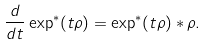Convert formula to latex. <formula><loc_0><loc_0><loc_500><loc_500>\frac { d } { d t } \exp ^ { * } ( t \rho ) = \exp ^ { * } ( t \rho ) * \rho .</formula> 